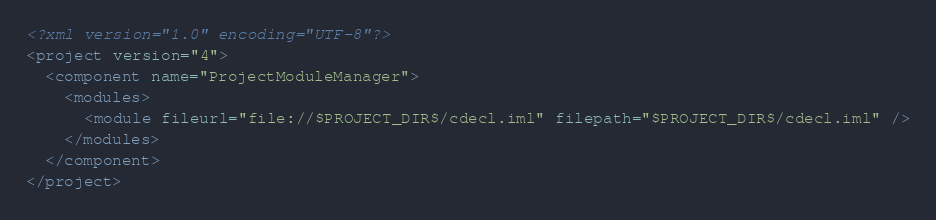Convert code to text. <code><loc_0><loc_0><loc_500><loc_500><_XML_><?xml version="1.0" encoding="UTF-8"?>
<project version="4">
  <component name="ProjectModuleManager">
    <modules>
      <module fileurl="file://$PROJECT_DIR$/cdecl.iml" filepath="$PROJECT_DIR$/cdecl.iml" />
    </modules>
  </component>
</project></code> 